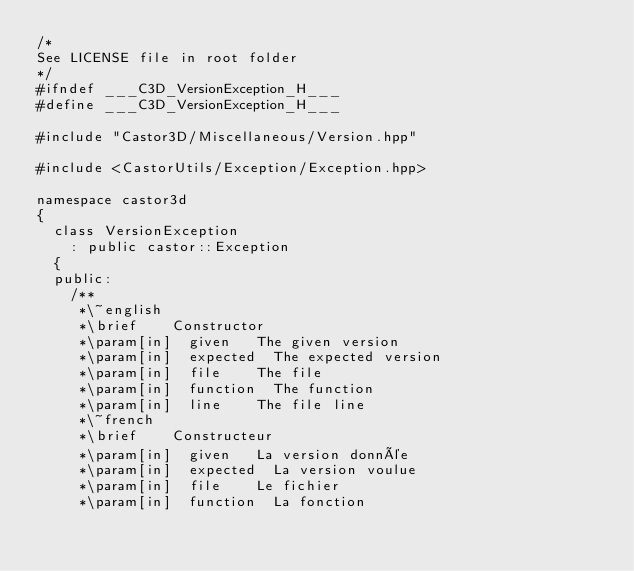Convert code to text. <code><loc_0><loc_0><loc_500><loc_500><_C++_>/*
See LICENSE file in root folder
*/
#ifndef ___C3D_VersionException_H___
#define ___C3D_VersionException_H___

#include "Castor3D/Miscellaneous/Version.hpp"

#include <CastorUtils/Exception/Exception.hpp>

namespace castor3d
{
	class VersionException
		: public castor::Exception
	{
	public:
		/**
		 *\~english
		 *\brief		Constructor
		 *\param[in]	given		The given version
		 *\param[in]	expected	The expected version
		 *\param[in]	file		The file
		 *\param[in]	function	The function
		 *\param[in]	line		The file line
		 *\~french
		 *\brief		Constructeur
		 *\param[in]	given		La version donnée
		 *\param[in]	expected	La version voulue
		 *\param[in]	file		Le fichier
		 *\param[in]	function	La fonction</code> 